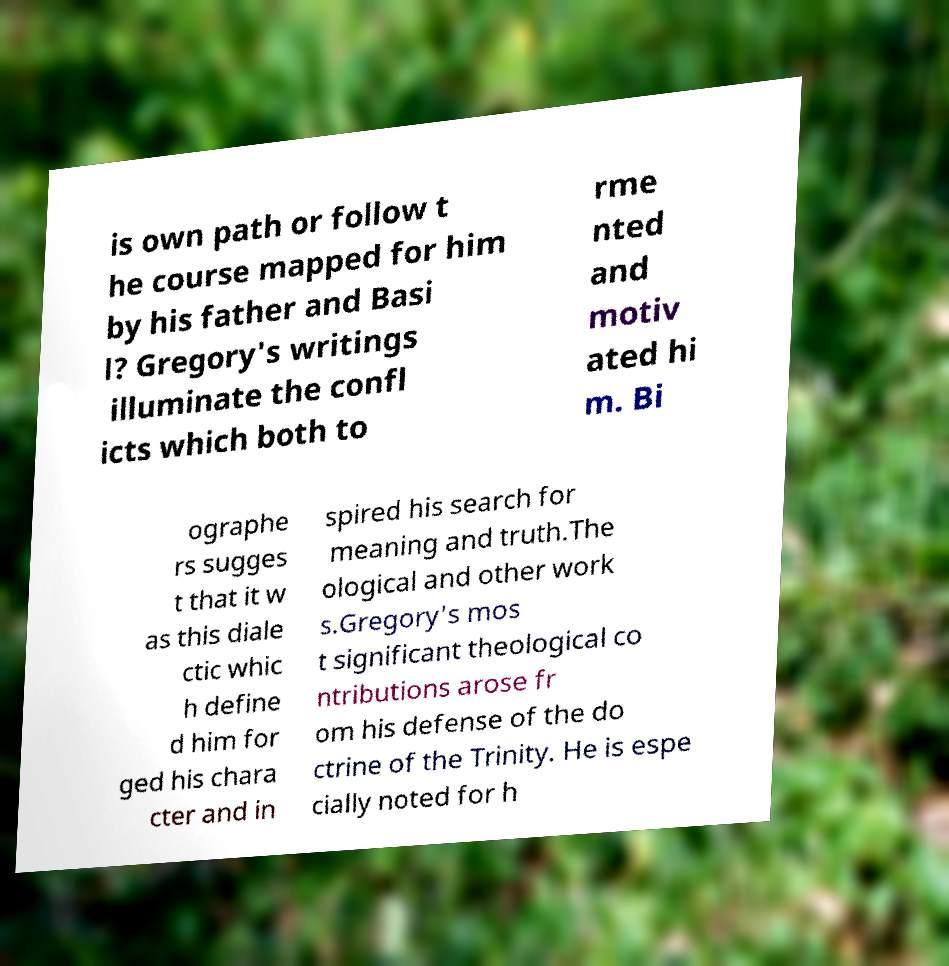Could you assist in decoding the text presented in this image and type it out clearly? is own path or follow t he course mapped for him by his father and Basi l? Gregory's writings illuminate the confl icts which both to rme nted and motiv ated hi m. Bi ographe rs sugges t that it w as this diale ctic whic h define d him for ged his chara cter and in spired his search for meaning and truth.The ological and other work s.Gregory's mos t significant theological co ntributions arose fr om his defense of the do ctrine of the Trinity. He is espe cially noted for h 